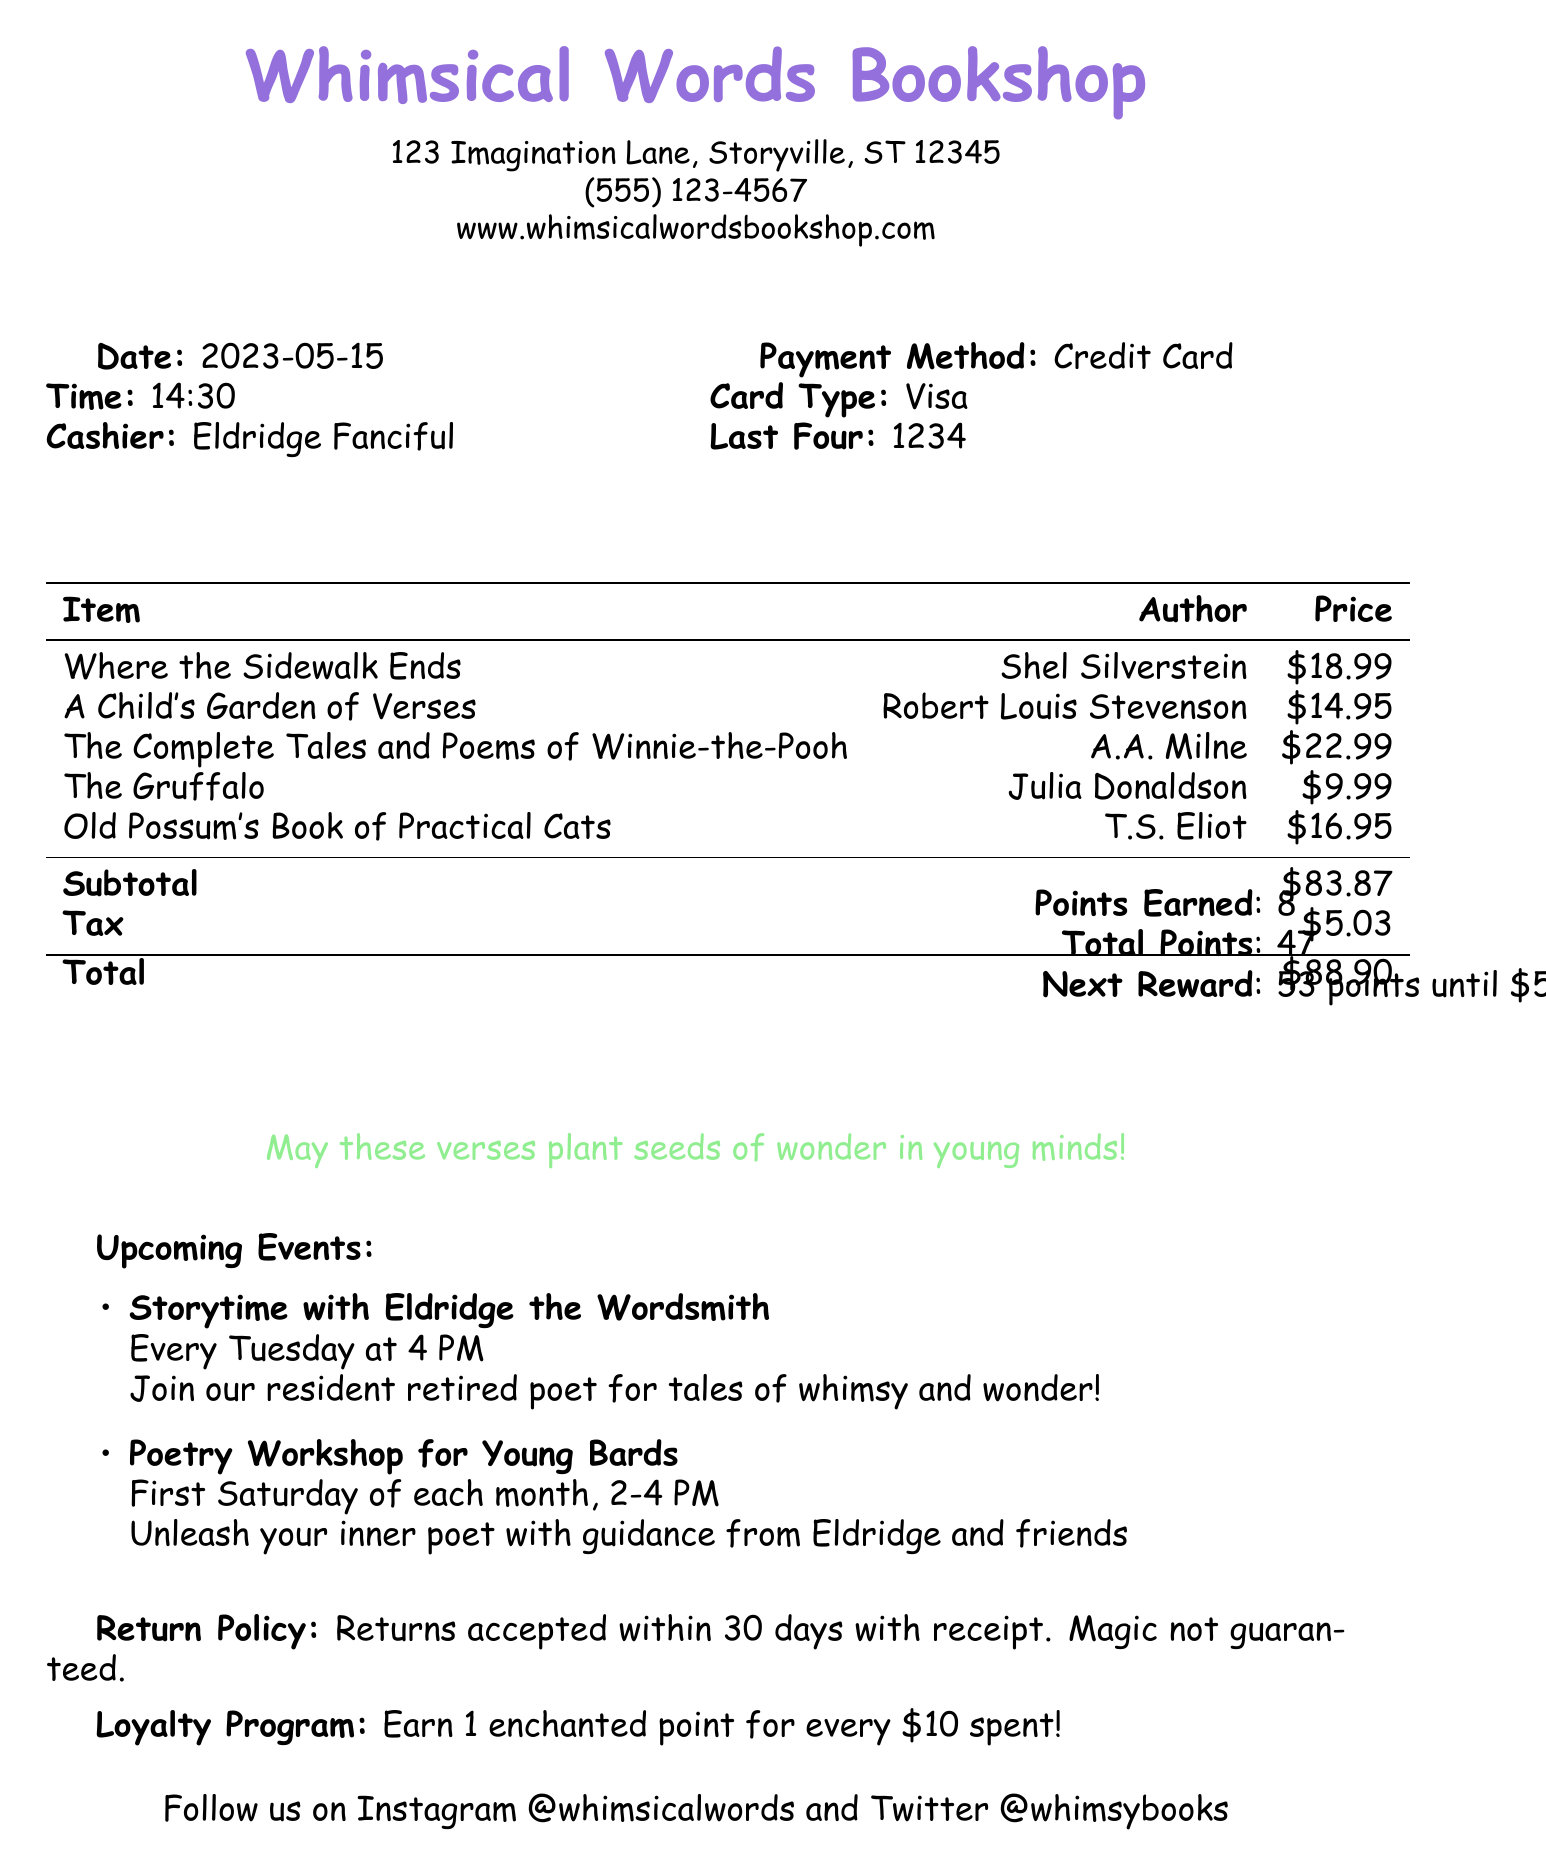What is the total amount spent? The total amount is the final sum listed on the receipt, which is the subtotal plus tax.
Answer: $88.90 Who was the cashier? The cashier's name is provided in the document under the cashier section of the receipt.
Answer: Eldridge Fanciful What loyalty points were earned from this purchase? The loyalty points earned are presented towards the bottom of the receipt, reflecting points accumulated from the purchase.
Answer: 8 What is the address of the bookstore? The address is listed at the top of the receipt and provides a specific location.
Answer: 123 Imagination Lane, Storyville, ST 12345 What illustration is described on the receipt? The illustration description is provided in the document and describes the artistic representation included with the receipt.
Answer: Hand-drawn magical tree with book-shaped leaves and candy cane trunk What upcoming event occurs every Tuesday? The receipt mentions specific events, including their frequency and details about the hosts and activities.
Answer: Storytime with Eldridge the Wordsmith How many total points are there in the loyalty program? The total points are stated clearly in the section dedicated to loyalty points earned and accumulated from prior purchases.
Answer: 47 What is the return policy? The return policy is outlined in one of the sections, detailing the conditions under which items may be returned.
Answer: Returns accepted within 30 days with receipt. Magic not guaranteed 